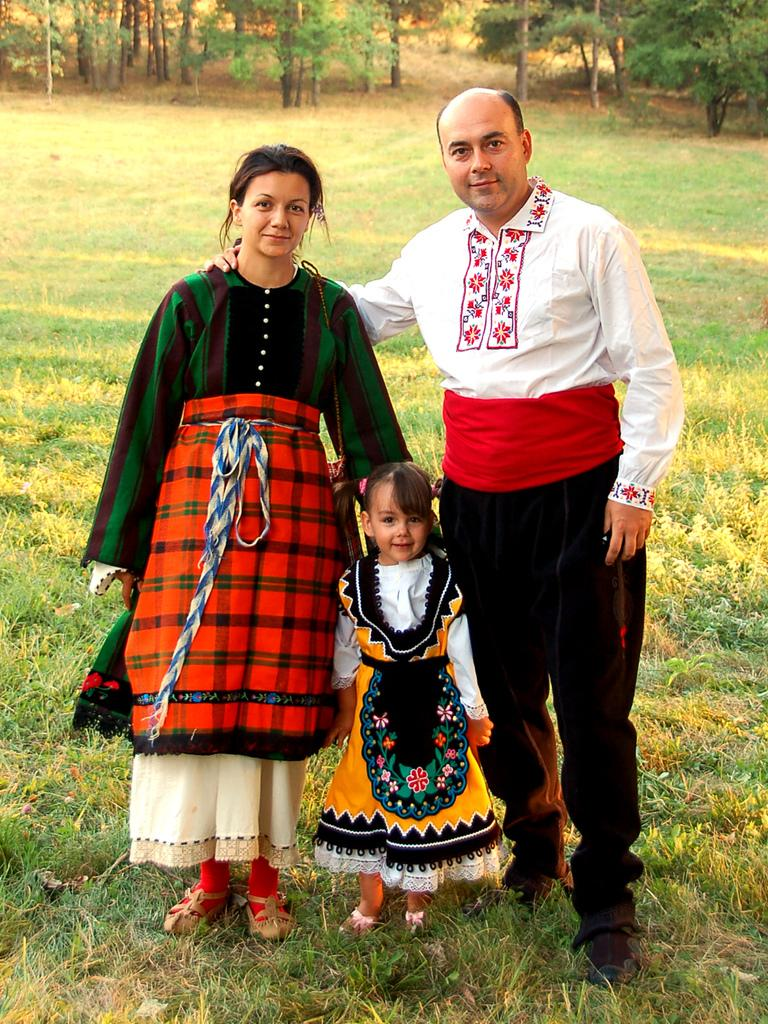How many people are in the image? There are three people in the image: a man, a woman, and a girl. What are the people in the image doing? The man, woman, and girl are standing on the grass. What can be seen in the background of the image? There are trees and grass in the background of the image. What type of seashore attraction can be seen in the image? There is no seashore or attraction present in the image; it features a man, woman, and girl standing on the grass with trees and grass in the background. What kind of carriage is being used by the people in the image? There is no carriage present in the image; the people are standing on the grass. 